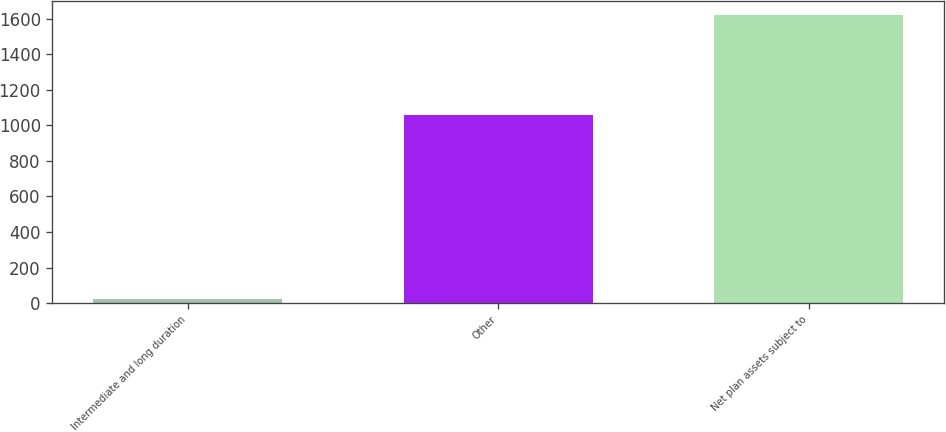<chart> <loc_0><loc_0><loc_500><loc_500><bar_chart><fcel>Intermediate and long duration<fcel>Other<fcel>Net plan assets subject to<nl><fcel>23<fcel>1060<fcel>1622<nl></chart> 